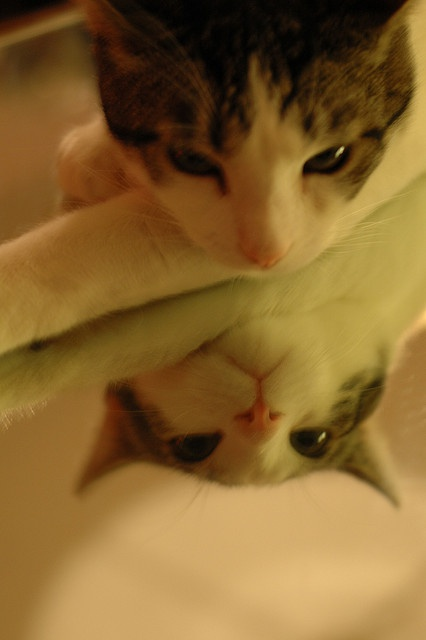Describe the objects in this image and their specific colors. I can see cat in black, maroon, and olive tones and cat in black, olive, tan, and maroon tones in this image. 